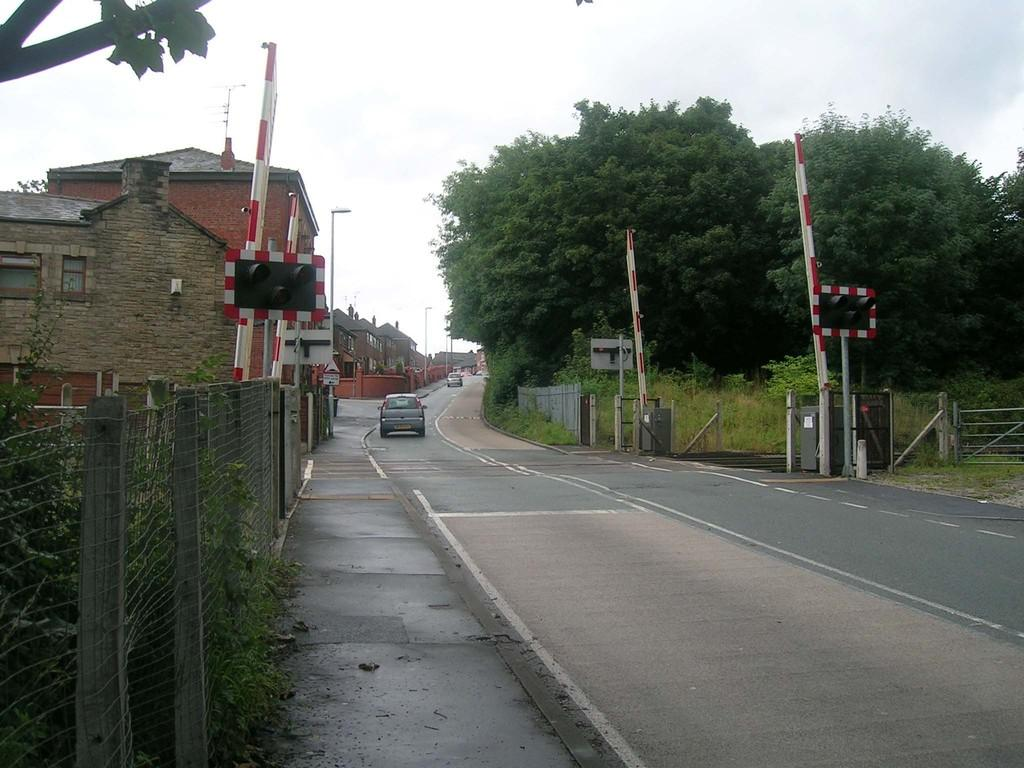What can be seen on the road in the image? There are vehicles on the road in the image. What type of structures can be seen in the image? There are fences, traffic signals on poles, and buildings in the background of the image. What type of vegetation is present in the image? There are plants and trees in the image. What can be seen in the sky in the background of the image? The sky is visible in the background of the image. Can you tell me how many owls are sitting on the traffic signals in the image? There are no owls present in the image; only vehicles, fences, plants, traffic signals, trees, buildings, lights, and the sky are visible. Is there a shop visible in the image? There is no shop present in the image. 